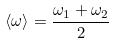<formula> <loc_0><loc_0><loc_500><loc_500>\langle \omega \rangle = \frac { \omega _ { 1 } + \omega _ { 2 } } { 2 }</formula> 